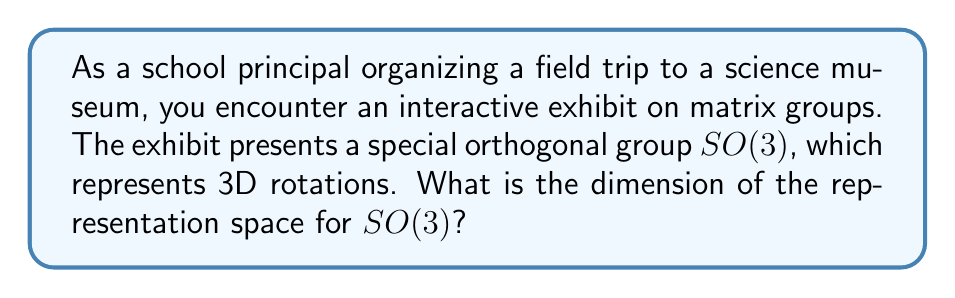What is the answer to this math problem? To find the dimension of the representation space for $SO(3)$, we need to follow these steps:

1) First, recall that $SO(3)$ is the group of 3×3 orthogonal matrices with determinant 1.

2) Each element of $SO(3)$ can be represented as a 3×3 matrix:

   $$\begin{pmatrix}
   a_{11} & a_{12} & a_{13} \\
   a_{21} & a_{22} & a_{23} \\
   a_{31} & a_{32} & a_{33}
   \end{pmatrix}$$

3) However, not all of these 9 entries are independent due to the orthogonality condition:

   $AA^T = I$ and $\det(A) = 1$

4) The orthogonality condition gives us 6 equations:

   $a_{11}^2 + a_{12}^2 + a_{13}^2 = 1$
   $a_{21}^2 + a_{22}^2 + a_{23}^2 = 1$
   $a_{31}^2 + a_{32}^2 + a_{33}^2 = 1$
   $a_{11}a_{21} + a_{12}a_{22} + a_{13}a_{23} = 0$
   $a_{11}a_{31} + a_{12}a_{32} + a_{13}a_{33} = 0$
   $a_{21}a_{31} + a_{22}a_{32} + a_{23}a_{33} = 0$

5) The determinant condition gives us one more equation.

6) These 7 equations reduce the number of independent parameters from 9 to 3.

7) Therefore, $SO(3)$ is a 3-dimensional Lie group.

8) In the standard representation, $SO(3)$ acts on 3-dimensional vectors.

9) Thus, the dimension of the representation space for $SO(3)$ is 3.
Answer: 3 